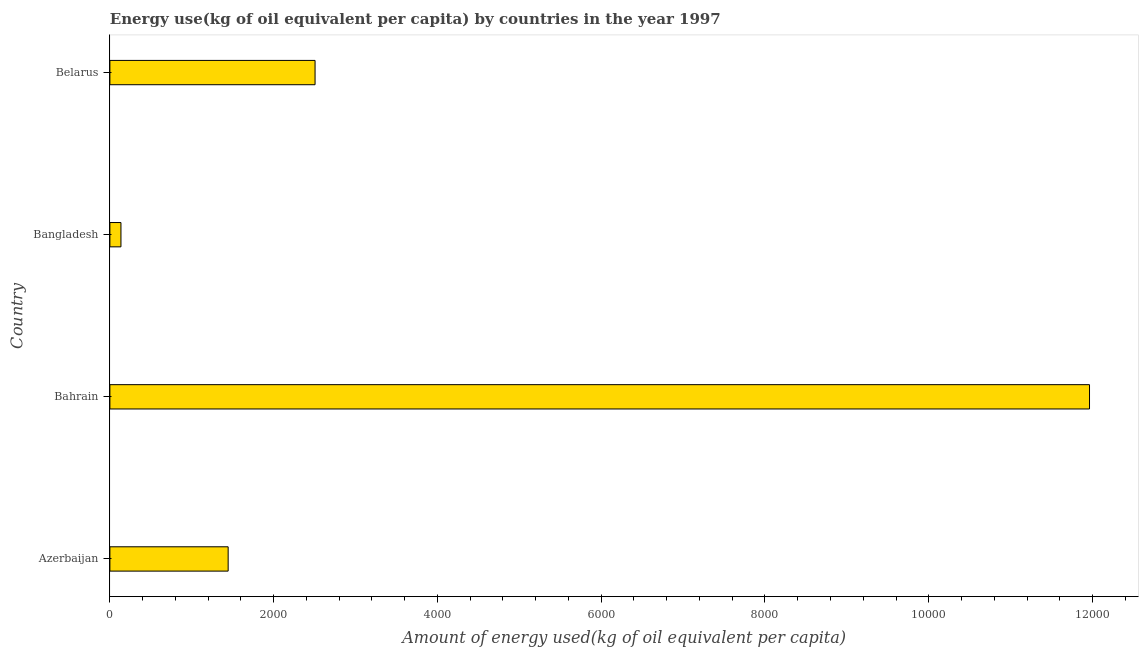What is the title of the graph?
Provide a succinct answer. Energy use(kg of oil equivalent per capita) by countries in the year 1997. What is the label or title of the X-axis?
Keep it short and to the point. Amount of energy used(kg of oil equivalent per capita). What is the label or title of the Y-axis?
Keep it short and to the point. Country. What is the amount of energy used in Belarus?
Make the answer very short. 2505.6. Across all countries, what is the maximum amount of energy used?
Your answer should be very brief. 1.20e+04. Across all countries, what is the minimum amount of energy used?
Your response must be concise. 135.18. In which country was the amount of energy used maximum?
Your response must be concise. Bahrain. In which country was the amount of energy used minimum?
Offer a terse response. Bangladesh. What is the sum of the amount of energy used?
Offer a terse response. 1.60e+04. What is the difference between the amount of energy used in Azerbaijan and Bahrain?
Your response must be concise. -1.05e+04. What is the average amount of energy used per country?
Make the answer very short. 4012.07. What is the median amount of energy used?
Give a very brief answer. 1974.96. In how many countries, is the amount of energy used greater than 10800 kg?
Keep it short and to the point. 1. What is the ratio of the amount of energy used in Bangladesh to that in Belarus?
Give a very brief answer. 0.05. Is the amount of energy used in Azerbaijan less than that in Bangladesh?
Your response must be concise. No. Is the difference between the amount of energy used in Azerbaijan and Bahrain greater than the difference between any two countries?
Ensure brevity in your answer.  No. What is the difference between the highest and the second highest amount of energy used?
Provide a succinct answer. 9457.56. Is the sum of the amount of energy used in Bahrain and Bangladesh greater than the maximum amount of energy used across all countries?
Keep it short and to the point. Yes. What is the difference between the highest and the lowest amount of energy used?
Offer a very short reply. 1.18e+04. How many bars are there?
Provide a short and direct response. 4. Are the values on the major ticks of X-axis written in scientific E-notation?
Your answer should be compact. No. What is the Amount of energy used(kg of oil equivalent per capita) of Azerbaijan?
Make the answer very short. 1444.32. What is the Amount of energy used(kg of oil equivalent per capita) in Bahrain?
Provide a short and direct response. 1.20e+04. What is the Amount of energy used(kg of oil equivalent per capita) of Bangladesh?
Offer a terse response. 135.18. What is the Amount of energy used(kg of oil equivalent per capita) of Belarus?
Make the answer very short. 2505.6. What is the difference between the Amount of energy used(kg of oil equivalent per capita) in Azerbaijan and Bahrain?
Your response must be concise. -1.05e+04. What is the difference between the Amount of energy used(kg of oil equivalent per capita) in Azerbaijan and Bangladesh?
Your answer should be very brief. 1309.14. What is the difference between the Amount of energy used(kg of oil equivalent per capita) in Azerbaijan and Belarus?
Offer a terse response. -1061.29. What is the difference between the Amount of energy used(kg of oil equivalent per capita) in Bahrain and Bangladesh?
Give a very brief answer. 1.18e+04. What is the difference between the Amount of energy used(kg of oil equivalent per capita) in Bahrain and Belarus?
Provide a succinct answer. 9457.56. What is the difference between the Amount of energy used(kg of oil equivalent per capita) in Bangladesh and Belarus?
Make the answer very short. -2370.42. What is the ratio of the Amount of energy used(kg of oil equivalent per capita) in Azerbaijan to that in Bahrain?
Ensure brevity in your answer.  0.12. What is the ratio of the Amount of energy used(kg of oil equivalent per capita) in Azerbaijan to that in Bangladesh?
Your answer should be compact. 10.68. What is the ratio of the Amount of energy used(kg of oil equivalent per capita) in Azerbaijan to that in Belarus?
Provide a succinct answer. 0.58. What is the ratio of the Amount of energy used(kg of oil equivalent per capita) in Bahrain to that in Bangladesh?
Make the answer very short. 88.5. What is the ratio of the Amount of energy used(kg of oil equivalent per capita) in Bahrain to that in Belarus?
Your answer should be very brief. 4.78. What is the ratio of the Amount of energy used(kg of oil equivalent per capita) in Bangladesh to that in Belarus?
Your answer should be compact. 0.05. 